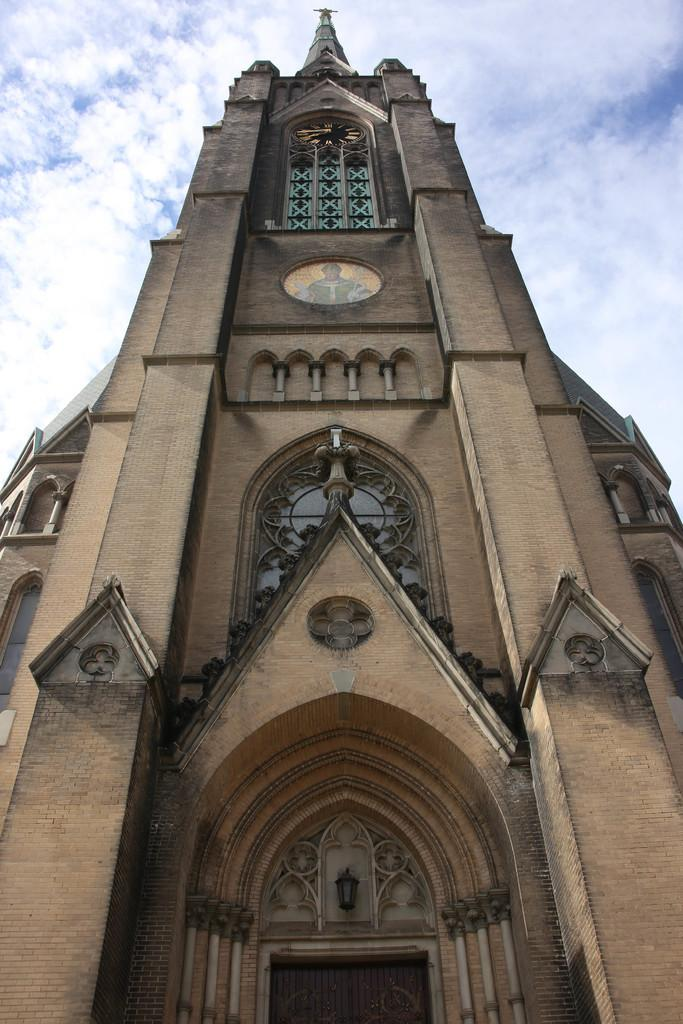What type of structure is present in the image? There is a building in the image. What can be seen in the background of the image? The sky is visible in the background of the image. Where are the spiders playing on the playground in the image? There is no playground or spiders present in the image; it only features a building and the sky. 